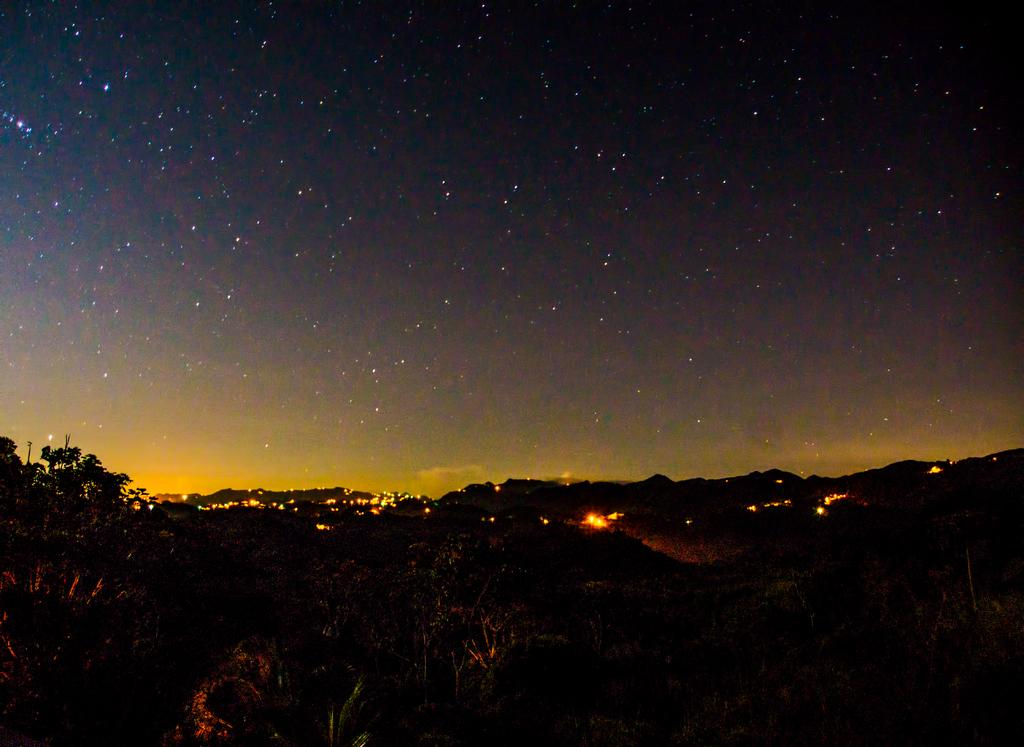What type of natural elements can be seen in the image? There are trees in the image. What artificial elements can be seen in the image? There are lights in the image. What is visible in the background of the image? The sky is visible in the background of the image. What type of vessel is being used to apply the texture to the trees in the image? There is no vessel or texture application process depicted in the image; it simply shows trees and lights. 